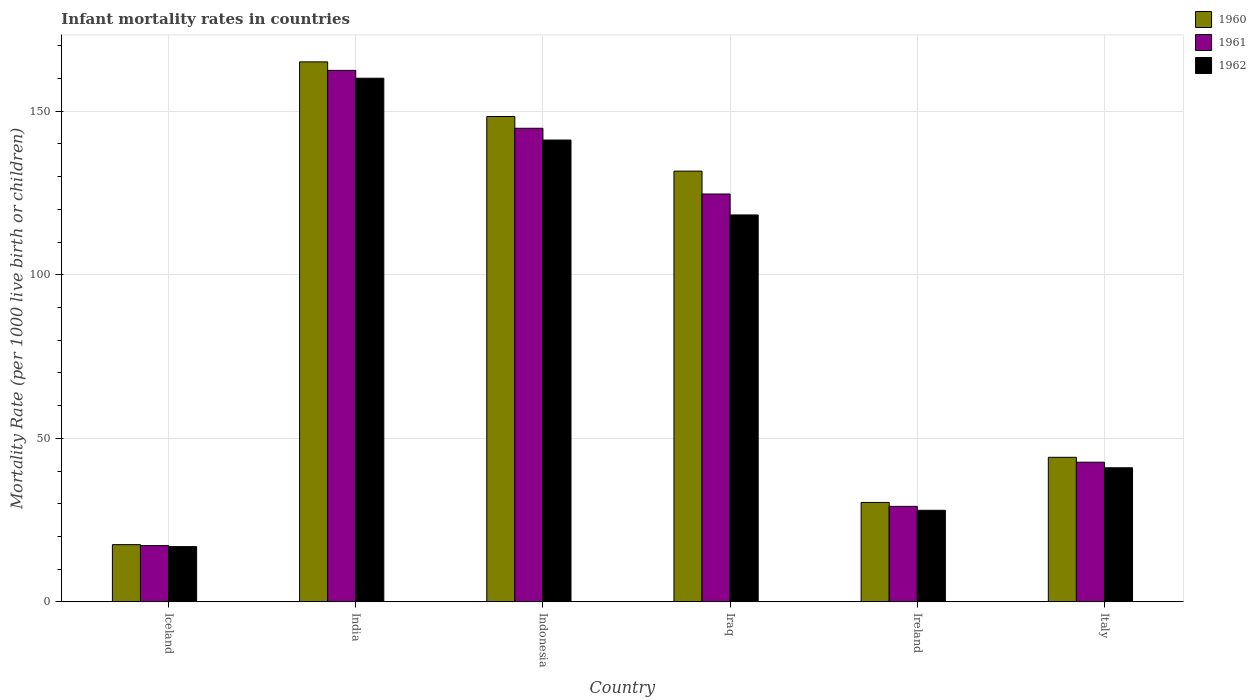How many different coloured bars are there?
Provide a succinct answer. 3. How many groups of bars are there?
Offer a terse response. 6. What is the label of the 2nd group of bars from the left?
Provide a succinct answer. India. What is the infant mortality rate in 1962 in Ireland?
Provide a short and direct response. 28. Across all countries, what is the maximum infant mortality rate in 1960?
Ensure brevity in your answer.  165.1. Across all countries, what is the minimum infant mortality rate in 1961?
Your response must be concise. 17.2. In which country was the infant mortality rate in 1962 minimum?
Ensure brevity in your answer.  Iceland. What is the total infant mortality rate in 1961 in the graph?
Provide a short and direct response. 521.1. What is the difference between the infant mortality rate in 1961 in Indonesia and that in Ireland?
Give a very brief answer. 115.6. What is the difference between the infant mortality rate in 1962 in India and the infant mortality rate in 1960 in Indonesia?
Keep it short and to the point. 11.7. What is the average infant mortality rate in 1960 per country?
Give a very brief answer. 89.55. What is the difference between the infant mortality rate of/in 1960 and infant mortality rate of/in 1961 in India?
Your answer should be very brief. 2.6. What is the ratio of the infant mortality rate in 1962 in Iraq to that in Italy?
Give a very brief answer. 2.89. Is the infant mortality rate in 1960 in India less than that in Ireland?
Your response must be concise. No. Is the difference between the infant mortality rate in 1960 in Indonesia and Italy greater than the difference between the infant mortality rate in 1961 in Indonesia and Italy?
Keep it short and to the point. Yes. What is the difference between the highest and the second highest infant mortality rate in 1960?
Provide a succinct answer. -16.7. What is the difference between the highest and the lowest infant mortality rate in 1962?
Your answer should be compact. 143.2. In how many countries, is the infant mortality rate in 1961 greater than the average infant mortality rate in 1961 taken over all countries?
Ensure brevity in your answer.  3. Is the sum of the infant mortality rate in 1962 in Iceland and Indonesia greater than the maximum infant mortality rate in 1961 across all countries?
Provide a short and direct response. No. What does the 3rd bar from the left in Italy represents?
Make the answer very short. 1962. What does the 2nd bar from the right in Iraq represents?
Give a very brief answer. 1961. Is it the case that in every country, the sum of the infant mortality rate in 1961 and infant mortality rate in 1962 is greater than the infant mortality rate in 1960?
Your answer should be very brief. Yes. How many countries are there in the graph?
Keep it short and to the point. 6. What is the difference between two consecutive major ticks on the Y-axis?
Make the answer very short. 50. Are the values on the major ticks of Y-axis written in scientific E-notation?
Give a very brief answer. No. What is the title of the graph?
Provide a succinct answer. Infant mortality rates in countries. Does "1973" appear as one of the legend labels in the graph?
Your response must be concise. No. What is the label or title of the Y-axis?
Provide a short and direct response. Mortality Rate (per 1000 live birth or children). What is the Mortality Rate (per 1000 live birth or children) of 1961 in Iceland?
Provide a short and direct response. 17.2. What is the Mortality Rate (per 1000 live birth or children) of 1962 in Iceland?
Provide a succinct answer. 16.9. What is the Mortality Rate (per 1000 live birth or children) of 1960 in India?
Provide a succinct answer. 165.1. What is the Mortality Rate (per 1000 live birth or children) in 1961 in India?
Your response must be concise. 162.5. What is the Mortality Rate (per 1000 live birth or children) in 1962 in India?
Ensure brevity in your answer.  160.1. What is the Mortality Rate (per 1000 live birth or children) of 1960 in Indonesia?
Give a very brief answer. 148.4. What is the Mortality Rate (per 1000 live birth or children) in 1961 in Indonesia?
Your answer should be compact. 144.8. What is the Mortality Rate (per 1000 live birth or children) of 1962 in Indonesia?
Make the answer very short. 141.2. What is the Mortality Rate (per 1000 live birth or children) in 1960 in Iraq?
Ensure brevity in your answer.  131.7. What is the Mortality Rate (per 1000 live birth or children) in 1961 in Iraq?
Keep it short and to the point. 124.7. What is the Mortality Rate (per 1000 live birth or children) in 1962 in Iraq?
Offer a terse response. 118.3. What is the Mortality Rate (per 1000 live birth or children) of 1960 in Ireland?
Keep it short and to the point. 30.4. What is the Mortality Rate (per 1000 live birth or children) in 1961 in Ireland?
Your answer should be compact. 29.2. What is the Mortality Rate (per 1000 live birth or children) of 1960 in Italy?
Your response must be concise. 44.2. What is the Mortality Rate (per 1000 live birth or children) in 1961 in Italy?
Provide a succinct answer. 42.7. What is the Mortality Rate (per 1000 live birth or children) of 1962 in Italy?
Provide a succinct answer. 41. Across all countries, what is the maximum Mortality Rate (per 1000 live birth or children) of 1960?
Offer a terse response. 165.1. Across all countries, what is the maximum Mortality Rate (per 1000 live birth or children) in 1961?
Provide a short and direct response. 162.5. Across all countries, what is the maximum Mortality Rate (per 1000 live birth or children) of 1962?
Ensure brevity in your answer.  160.1. Across all countries, what is the minimum Mortality Rate (per 1000 live birth or children) of 1960?
Give a very brief answer. 17.5. Across all countries, what is the minimum Mortality Rate (per 1000 live birth or children) in 1961?
Provide a succinct answer. 17.2. Across all countries, what is the minimum Mortality Rate (per 1000 live birth or children) in 1962?
Your answer should be compact. 16.9. What is the total Mortality Rate (per 1000 live birth or children) in 1960 in the graph?
Your response must be concise. 537.3. What is the total Mortality Rate (per 1000 live birth or children) in 1961 in the graph?
Give a very brief answer. 521.1. What is the total Mortality Rate (per 1000 live birth or children) in 1962 in the graph?
Provide a short and direct response. 505.5. What is the difference between the Mortality Rate (per 1000 live birth or children) of 1960 in Iceland and that in India?
Offer a terse response. -147.6. What is the difference between the Mortality Rate (per 1000 live birth or children) in 1961 in Iceland and that in India?
Provide a succinct answer. -145.3. What is the difference between the Mortality Rate (per 1000 live birth or children) of 1962 in Iceland and that in India?
Keep it short and to the point. -143.2. What is the difference between the Mortality Rate (per 1000 live birth or children) of 1960 in Iceland and that in Indonesia?
Your answer should be compact. -130.9. What is the difference between the Mortality Rate (per 1000 live birth or children) in 1961 in Iceland and that in Indonesia?
Offer a very short reply. -127.6. What is the difference between the Mortality Rate (per 1000 live birth or children) of 1962 in Iceland and that in Indonesia?
Your answer should be very brief. -124.3. What is the difference between the Mortality Rate (per 1000 live birth or children) of 1960 in Iceland and that in Iraq?
Provide a succinct answer. -114.2. What is the difference between the Mortality Rate (per 1000 live birth or children) of 1961 in Iceland and that in Iraq?
Make the answer very short. -107.5. What is the difference between the Mortality Rate (per 1000 live birth or children) of 1962 in Iceland and that in Iraq?
Ensure brevity in your answer.  -101.4. What is the difference between the Mortality Rate (per 1000 live birth or children) in 1960 in Iceland and that in Ireland?
Give a very brief answer. -12.9. What is the difference between the Mortality Rate (per 1000 live birth or children) of 1961 in Iceland and that in Ireland?
Give a very brief answer. -12. What is the difference between the Mortality Rate (per 1000 live birth or children) of 1962 in Iceland and that in Ireland?
Your response must be concise. -11.1. What is the difference between the Mortality Rate (per 1000 live birth or children) in 1960 in Iceland and that in Italy?
Offer a terse response. -26.7. What is the difference between the Mortality Rate (per 1000 live birth or children) of 1961 in Iceland and that in Italy?
Provide a short and direct response. -25.5. What is the difference between the Mortality Rate (per 1000 live birth or children) in 1962 in Iceland and that in Italy?
Offer a terse response. -24.1. What is the difference between the Mortality Rate (per 1000 live birth or children) of 1960 in India and that in Indonesia?
Provide a short and direct response. 16.7. What is the difference between the Mortality Rate (per 1000 live birth or children) in 1961 in India and that in Indonesia?
Offer a terse response. 17.7. What is the difference between the Mortality Rate (per 1000 live birth or children) of 1960 in India and that in Iraq?
Your answer should be compact. 33.4. What is the difference between the Mortality Rate (per 1000 live birth or children) of 1961 in India and that in Iraq?
Keep it short and to the point. 37.8. What is the difference between the Mortality Rate (per 1000 live birth or children) of 1962 in India and that in Iraq?
Make the answer very short. 41.8. What is the difference between the Mortality Rate (per 1000 live birth or children) of 1960 in India and that in Ireland?
Your response must be concise. 134.7. What is the difference between the Mortality Rate (per 1000 live birth or children) of 1961 in India and that in Ireland?
Your answer should be very brief. 133.3. What is the difference between the Mortality Rate (per 1000 live birth or children) in 1962 in India and that in Ireland?
Your response must be concise. 132.1. What is the difference between the Mortality Rate (per 1000 live birth or children) of 1960 in India and that in Italy?
Your answer should be compact. 120.9. What is the difference between the Mortality Rate (per 1000 live birth or children) in 1961 in India and that in Italy?
Give a very brief answer. 119.8. What is the difference between the Mortality Rate (per 1000 live birth or children) of 1962 in India and that in Italy?
Ensure brevity in your answer.  119.1. What is the difference between the Mortality Rate (per 1000 live birth or children) in 1961 in Indonesia and that in Iraq?
Ensure brevity in your answer.  20.1. What is the difference between the Mortality Rate (per 1000 live birth or children) in 1962 in Indonesia and that in Iraq?
Offer a very short reply. 22.9. What is the difference between the Mortality Rate (per 1000 live birth or children) of 1960 in Indonesia and that in Ireland?
Offer a terse response. 118. What is the difference between the Mortality Rate (per 1000 live birth or children) of 1961 in Indonesia and that in Ireland?
Make the answer very short. 115.6. What is the difference between the Mortality Rate (per 1000 live birth or children) in 1962 in Indonesia and that in Ireland?
Your response must be concise. 113.2. What is the difference between the Mortality Rate (per 1000 live birth or children) in 1960 in Indonesia and that in Italy?
Make the answer very short. 104.2. What is the difference between the Mortality Rate (per 1000 live birth or children) in 1961 in Indonesia and that in Italy?
Offer a very short reply. 102.1. What is the difference between the Mortality Rate (per 1000 live birth or children) of 1962 in Indonesia and that in Italy?
Ensure brevity in your answer.  100.2. What is the difference between the Mortality Rate (per 1000 live birth or children) in 1960 in Iraq and that in Ireland?
Your answer should be compact. 101.3. What is the difference between the Mortality Rate (per 1000 live birth or children) of 1961 in Iraq and that in Ireland?
Keep it short and to the point. 95.5. What is the difference between the Mortality Rate (per 1000 live birth or children) in 1962 in Iraq and that in Ireland?
Your answer should be very brief. 90.3. What is the difference between the Mortality Rate (per 1000 live birth or children) of 1960 in Iraq and that in Italy?
Offer a terse response. 87.5. What is the difference between the Mortality Rate (per 1000 live birth or children) in 1961 in Iraq and that in Italy?
Keep it short and to the point. 82. What is the difference between the Mortality Rate (per 1000 live birth or children) in 1962 in Iraq and that in Italy?
Your response must be concise. 77.3. What is the difference between the Mortality Rate (per 1000 live birth or children) in 1961 in Ireland and that in Italy?
Keep it short and to the point. -13.5. What is the difference between the Mortality Rate (per 1000 live birth or children) of 1962 in Ireland and that in Italy?
Give a very brief answer. -13. What is the difference between the Mortality Rate (per 1000 live birth or children) in 1960 in Iceland and the Mortality Rate (per 1000 live birth or children) in 1961 in India?
Provide a succinct answer. -145. What is the difference between the Mortality Rate (per 1000 live birth or children) of 1960 in Iceland and the Mortality Rate (per 1000 live birth or children) of 1962 in India?
Offer a terse response. -142.6. What is the difference between the Mortality Rate (per 1000 live birth or children) in 1961 in Iceland and the Mortality Rate (per 1000 live birth or children) in 1962 in India?
Provide a succinct answer. -142.9. What is the difference between the Mortality Rate (per 1000 live birth or children) of 1960 in Iceland and the Mortality Rate (per 1000 live birth or children) of 1961 in Indonesia?
Keep it short and to the point. -127.3. What is the difference between the Mortality Rate (per 1000 live birth or children) in 1960 in Iceland and the Mortality Rate (per 1000 live birth or children) in 1962 in Indonesia?
Your answer should be very brief. -123.7. What is the difference between the Mortality Rate (per 1000 live birth or children) of 1961 in Iceland and the Mortality Rate (per 1000 live birth or children) of 1962 in Indonesia?
Make the answer very short. -124. What is the difference between the Mortality Rate (per 1000 live birth or children) in 1960 in Iceland and the Mortality Rate (per 1000 live birth or children) in 1961 in Iraq?
Provide a succinct answer. -107.2. What is the difference between the Mortality Rate (per 1000 live birth or children) of 1960 in Iceland and the Mortality Rate (per 1000 live birth or children) of 1962 in Iraq?
Offer a very short reply. -100.8. What is the difference between the Mortality Rate (per 1000 live birth or children) in 1961 in Iceland and the Mortality Rate (per 1000 live birth or children) in 1962 in Iraq?
Offer a terse response. -101.1. What is the difference between the Mortality Rate (per 1000 live birth or children) in 1960 in Iceland and the Mortality Rate (per 1000 live birth or children) in 1961 in Italy?
Your answer should be very brief. -25.2. What is the difference between the Mortality Rate (per 1000 live birth or children) in 1960 in Iceland and the Mortality Rate (per 1000 live birth or children) in 1962 in Italy?
Keep it short and to the point. -23.5. What is the difference between the Mortality Rate (per 1000 live birth or children) in 1961 in Iceland and the Mortality Rate (per 1000 live birth or children) in 1962 in Italy?
Provide a short and direct response. -23.8. What is the difference between the Mortality Rate (per 1000 live birth or children) of 1960 in India and the Mortality Rate (per 1000 live birth or children) of 1961 in Indonesia?
Your answer should be very brief. 20.3. What is the difference between the Mortality Rate (per 1000 live birth or children) of 1960 in India and the Mortality Rate (per 1000 live birth or children) of 1962 in Indonesia?
Keep it short and to the point. 23.9. What is the difference between the Mortality Rate (per 1000 live birth or children) of 1961 in India and the Mortality Rate (per 1000 live birth or children) of 1962 in Indonesia?
Make the answer very short. 21.3. What is the difference between the Mortality Rate (per 1000 live birth or children) in 1960 in India and the Mortality Rate (per 1000 live birth or children) in 1961 in Iraq?
Offer a very short reply. 40.4. What is the difference between the Mortality Rate (per 1000 live birth or children) in 1960 in India and the Mortality Rate (per 1000 live birth or children) in 1962 in Iraq?
Provide a succinct answer. 46.8. What is the difference between the Mortality Rate (per 1000 live birth or children) of 1961 in India and the Mortality Rate (per 1000 live birth or children) of 1962 in Iraq?
Give a very brief answer. 44.2. What is the difference between the Mortality Rate (per 1000 live birth or children) of 1960 in India and the Mortality Rate (per 1000 live birth or children) of 1961 in Ireland?
Ensure brevity in your answer.  135.9. What is the difference between the Mortality Rate (per 1000 live birth or children) of 1960 in India and the Mortality Rate (per 1000 live birth or children) of 1962 in Ireland?
Provide a short and direct response. 137.1. What is the difference between the Mortality Rate (per 1000 live birth or children) of 1961 in India and the Mortality Rate (per 1000 live birth or children) of 1962 in Ireland?
Keep it short and to the point. 134.5. What is the difference between the Mortality Rate (per 1000 live birth or children) in 1960 in India and the Mortality Rate (per 1000 live birth or children) in 1961 in Italy?
Ensure brevity in your answer.  122.4. What is the difference between the Mortality Rate (per 1000 live birth or children) in 1960 in India and the Mortality Rate (per 1000 live birth or children) in 1962 in Italy?
Make the answer very short. 124.1. What is the difference between the Mortality Rate (per 1000 live birth or children) of 1961 in India and the Mortality Rate (per 1000 live birth or children) of 1962 in Italy?
Provide a short and direct response. 121.5. What is the difference between the Mortality Rate (per 1000 live birth or children) in 1960 in Indonesia and the Mortality Rate (per 1000 live birth or children) in 1961 in Iraq?
Provide a succinct answer. 23.7. What is the difference between the Mortality Rate (per 1000 live birth or children) of 1960 in Indonesia and the Mortality Rate (per 1000 live birth or children) of 1962 in Iraq?
Offer a terse response. 30.1. What is the difference between the Mortality Rate (per 1000 live birth or children) of 1961 in Indonesia and the Mortality Rate (per 1000 live birth or children) of 1962 in Iraq?
Give a very brief answer. 26.5. What is the difference between the Mortality Rate (per 1000 live birth or children) in 1960 in Indonesia and the Mortality Rate (per 1000 live birth or children) in 1961 in Ireland?
Your answer should be compact. 119.2. What is the difference between the Mortality Rate (per 1000 live birth or children) of 1960 in Indonesia and the Mortality Rate (per 1000 live birth or children) of 1962 in Ireland?
Offer a terse response. 120.4. What is the difference between the Mortality Rate (per 1000 live birth or children) of 1961 in Indonesia and the Mortality Rate (per 1000 live birth or children) of 1962 in Ireland?
Your answer should be very brief. 116.8. What is the difference between the Mortality Rate (per 1000 live birth or children) in 1960 in Indonesia and the Mortality Rate (per 1000 live birth or children) in 1961 in Italy?
Keep it short and to the point. 105.7. What is the difference between the Mortality Rate (per 1000 live birth or children) of 1960 in Indonesia and the Mortality Rate (per 1000 live birth or children) of 1962 in Italy?
Provide a succinct answer. 107.4. What is the difference between the Mortality Rate (per 1000 live birth or children) of 1961 in Indonesia and the Mortality Rate (per 1000 live birth or children) of 1962 in Italy?
Provide a short and direct response. 103.8. What is the difference between the Mortality Rate (per 1000 live birth or children) of 1960 in Iraq and the Mortality Rate (per 1000 live birth or children) of 1961 in Ireland?
Your answer should be very brief. 102.5. What is the difference between the Mortality Rate (per 1000 live birth or children) of 1960 in Iraq and the Mortality Rate (per 1000 live birth or children) of 1962 in Ireland?
Make the answer very short. 103.7. What is the difference between the Mortality Rate (per 1000 live birth or children) of 1961 in Iraq and the Mortality Rate (per 1000 live birth or children) of 1962 in Ireland?
Your response must be concise. 96.7. What is the difference between the Mortality Rate (per 1000 live birth or children) of 1960 in Iraq and the Mortality Rate (per 1000 live birth or children) of 1961 in Italy?
Your answer should be very brief. 89. What is the difference between the Mortality Rate (per 1000 live birth or children) in 1960 in Iraq and the Mortality Rate (per 1000 live birth or children) in 1962 in Italy?
Ensure brevity in your answer.  90.7. What is the difference between the Mortality Rate (per 1000 live birth or children) in 1961 in Iraq and the Mortality Rate (per 1000 live birth or children) in 1962 in Italy?
Your answer should be compact. 83.7. What is the difference between the Mortality Rate (per 1000 live birth or children) of 1960 in Ireland and the Mortality Rate (per 1000 live birth or children) of 1961 in Italy?
Make the answer very short. -12.3. What is the difference between the Mortality Rate (per 1000 live birth or children) in 1960 in Ireland and the Mortality Rate (per 1000 live birth or children) in 1962 in Italy?
Your answer should be very brief. -10.6. What is the average Mortality Rate (per 1000 live birth or children) of 1960 per country?
Offer a terse response. 89.55. What is the average Mortality Rate (per 1000 live birth or children) in 1961 per country?
Give a very brief answer. 86.85. What is the average Mortality Rate (per 1000 live birth or children) in 1962 per country?
Your answer should be compact. 84.25. What is the difference between the Mortality Rate (per 1000 live birth or children) of 1960 and Mortality Rate (per 1000 live birth or children) of 1961 in Iceland?
Provide a succinct answer. 0.3. What is the difference between the Mortality Rate (per 1000 live birth or children) of 1961 and Mortality Rate (per 1000 live birth or children) of 1962 in Iceland?
Provide a succinct answer. 0.3. What is the difference between the Mortality Rate (per 1000 live birth or children) of 1960 and Mortality Rate (per 1000 live birth or children) of 1961 in India?
Offer a terse response. 2.6. What is the difference between the Mortality Rate (per 1000 live birth or children) in 1960 and Mortality Rate (per 1000 live birth or children) in 1961 in Iraq?
Ensure brevity in your answer.  7. What is the difference between the Mortality Rate (per 1000 live birth or children) in 1961 and Mortality Rate (per 1000 live birth or children) in 1962 in Iraq?
Offer a terse response. 6.4. What is the difference between the Mortality Rate (per 1000 live birth or children) of 1960 and Mortality Rate (per 1000 live birth or children) of 1961 in Ireland?
Provide a succinct answer. 1.2. What is the difference between the Mortality Rate (per 1000 live birth or children) in 1961 and Mortality Rate (per 1000 live birth or children) in 1962 in Ireland?
Offer a terse response. 1.2. What is the difference between the Mortality Rate (per 1000 live birth or children) in 1960 and Mortality Rate (per 1000 live birth or children) in 1962 in Italy?
Your answer should be compact. 3.2. What is the difference between the Mortality Rate (per 1000 live birth or children) in 1961 and Mortality Rate (per 1000 live birth or children) in 1962 in Italy?
Your response must be concise. 1.7. What is the ratio of the Mortality Rate (per 1000 live birth or children) in 1960 in Iceland to that in India?
Your response must be concise. 0.11. What is the ratio of the Mortality Rate (per 1000 live birth or children) in 1961 in Iceland to that in India?
Keep it short and to the point. 0.11. What is the ratio of the Mortality Rate (per 1000 live birth or children) in 1962 in Iceland to that in India?
Make the answer very short. 0.11. What is the ratio of the Mortality Rate (per 1000 live birth or children) in 1960 in Iceland to that in Indonesia?
Give a very brief answer. 0.12. What is the ratio of the Mortality Rate (per 1000 live birth or children) in 1961 in Iceland to that in Indonesia?
Provide a short and direct response. 0.12. What is the ratio of the Mortality Rate (per 1000 live birth or children) of 1962 in Iceland to that in Indonesia?
Ensure brevity in your answer.  0.12. What is the ratio of the Mortality Rate (per 1000 live birth or children) of 1960 in Iceland to that in Iraq?
Provide a short and direct response. 0.13. What is the ratio of the Mortality Rate (per 1000 live birth or children) of 1961 in Iceland to that in Iraq?
Provide a short and direct response. 0.14. What is the ratio of the Mortality Rate (per 1000 live birth or children) in 1962 in Iceland to that in Iraq?
Your response must be concise. 0.14. What is the ratio of the Mortality Rate (per 1000 live birth or children) in 1960 in Iceland to that in Ireland?
Your answer should be very brief. 0.58. What is the ratio of the Mortality Rate (per 1000 live birth or children) of 1961 in Iceland to that in Ireland?
Offer a terse response. 0.59. What is the ratio of the Mortality Rate (per 1000 live birth or children) in 1962 in Iceland to that in Ireland?
Make the answer very short. 0.6. What is the ratio of the Mortality Rate (per 1000 live birth or children) of 1960 in Iceland to that in Italy?
Give a very brief answer. 0.4. What is the ratio of the Mortality Rate (per 1000 live birth or children) of 1961 in Iceland to that in Italy?
Keep it short and to the point. 0.4. What is the ratio of the Mortality Rate (per 1000 live birth or children) of 1962 in Iceland to that in Italy?
Offer a terse response. 0.41. What is the ratio of the Mortality Rate (per 1000 live birth or children) of 1960 in India to that in Indonesia?
Ensure brevity in your answer.  1.11. What is the ratio of the Mortality Rate (per 1000 live birth or children) in 1961 in India to that in Indonesia?
Provide a succinct answer. 1.12. What is the ratio of the Mortality Rate (per 1000 live birth or children) of 1962 in India to that in Indonesia?
Your response must be concise. 1.13. What is the ratio of the Mortality Rate (per 1000 live birth or children) of 1960 in India to that in Iraq?
Offer a terse response. 1.25. What is the ratio of the Mortality Rate (per 1000 live birth or children) of 1961 in India to that in Iraq?
Your answer should be compact. 1.3. What is the ratio of the Mortality Rate (per 1000 live birth or children) in 1962 in India to that in Iraq?
Provide a succinct answer. 1.35. What is the ratio of the Mortality Rate (per 1000 live birth or children) in 1960 in India to that in Ireland?
Give a very brief answer. 5.43. What is the ratio of the Mortality Rate (per 1000 live birth or children) of 1961 in India to that in Ireland?
Provide a succinct answer. 5.57. What is the ratio of the Mortality Rate (per 1000 live birth or children) in 1962 in India to that in Ireland?
Offer a very short reply. 5.72. What is the ratio of the Mortality Rate (per 1000 live birth or children) of 1960 in India to that in Italy?
Your response must be concise. 3.74. What is the ratio of the Mortality Rate (per 1000 live birth or children) in 1961 in India to that in Italy?
Provide a short and direct response. 3.81. What is the ratio of the Mortality Rate (per 1000 live birth or children) of 1962 in India to that in Italy?
Provide a succinct answer. 3.9. What is the ratio of the Mortality Rate (per 1000 live birth or children) in 1960 in Indonesia to that in Iraq?
Offer a very short reply. 1.13. What is the ratio of the Mortality Rate (per 1000 live birth or children) of 1961 in Indonesia to that in Iraq?
Offer a terse response. 1.16. What is the ratio of the Mortality Rate (per 1000 live birth or children) of 1962 in Indonesia to that in Iraq?
Provide a short and direct response. 1.19. What is the ratio of the Mortality Rate (per 1000 live birth or children) of 1960 in Indonesia to that in Ireland?
Make the answer very short. 4.88. What is the ratio of the Mortality Rate (per 1000 live birth or children) in 1961 in Indonesia to that in Ireland?
Your response must be concise. 4.96. What is the ratio of the Mortality Rate (per 1000 live birth or children) in 1962 in Indonesia to that in Ireland?
Your answer should be compact. 5.04. What is the ratio of the Mortality Rate (per 1000 live birth or children) in 1960 in Indonesia to that in Italy?
Ensure brevity in your answer.  3.36. What is the ratio of the Mortality Rate (per 1000 live birth or children) in 1961 in Indonesia to that in Italy?
Your answer should be compact. 3.39. What is the ratio of the Mortality Rate (per 1000 live birth or children) in 1962 in Indonesia to that in Italy?
Provide a succinct answer. 3.44. What is the ratio of the Mortality Rate (per 1000 live birth or children) in 1960 in Iraq to that in Ireland?
Offer a terse response. 4.33. What is the ratio of the Mortality Rate (per 1000 live birth or children) of 1961 in Iraq to that in Ireland?
Your answer should be very brief. 4.27. What is the ratio of the Mortality Rate (per 1000 live birth or children) of 1962 in Iraq to that in Ireland?
Provide a succinct answer. 4.22. What is the ratio of the Mortality Rate (per 1000 live birth or children) in 1960 in Iraq to that in Italy?
Your answer should be very brief. 2.98. What is the ratio of the Mortality Rate (per 1000 live birth or children) in 1961 in Iraq to that in Italy?
Make the answer very short. 2.92. What is the ratio of the Mortality Rate (per 1000 live birth or children) in 1962 in Iraq to that in Italy?
Make the answer very short. 2.89. What is the ratio of the Mortality Rate (per 1000 live birth or children) in 1960 in Ireland to that in Italy?
Give a very brief answer. 0.69. What is the ratio of the Mortality Rate (per 1000 live birth or children) of 1961 in Ireland to that in Italy?
Offer a very short reply. 0.68. What is the ratio of the Mortality Rate (per 1000 live birth or children) in 1962 in Ireland to that in Italy?
Your response must be concise. 0.68. What is the difference between the highest and the second highest Mortality Rate (per 1000 live birth or children) of 1960?
Your response must be concise. 16.7. What is the difference between the highest and the second highest Mortality Rate (per 1000 live birth or children) in 1961?
Make the answer very short. 17.7. What is the difference between the highest and the second highest Mortality Rate (per 1000 live birth or children) of 1962?
Keep it short and to the point. 18.9. What is the difference between the highest and the lowest Mortality Rate (per 1000 live birth or children) in 1960?
Give a very brief answer. 147.6. What is the difference between the highest and the lowest Mortality Rate (per 1000 live birth or children) of 1961?
Ensure brevity in your answer.  145.3. What is the difference between the highest and the lowest Mortality Rate (per 1000 live birth or children) of 1962?
Offer a terse response. 143.2. 